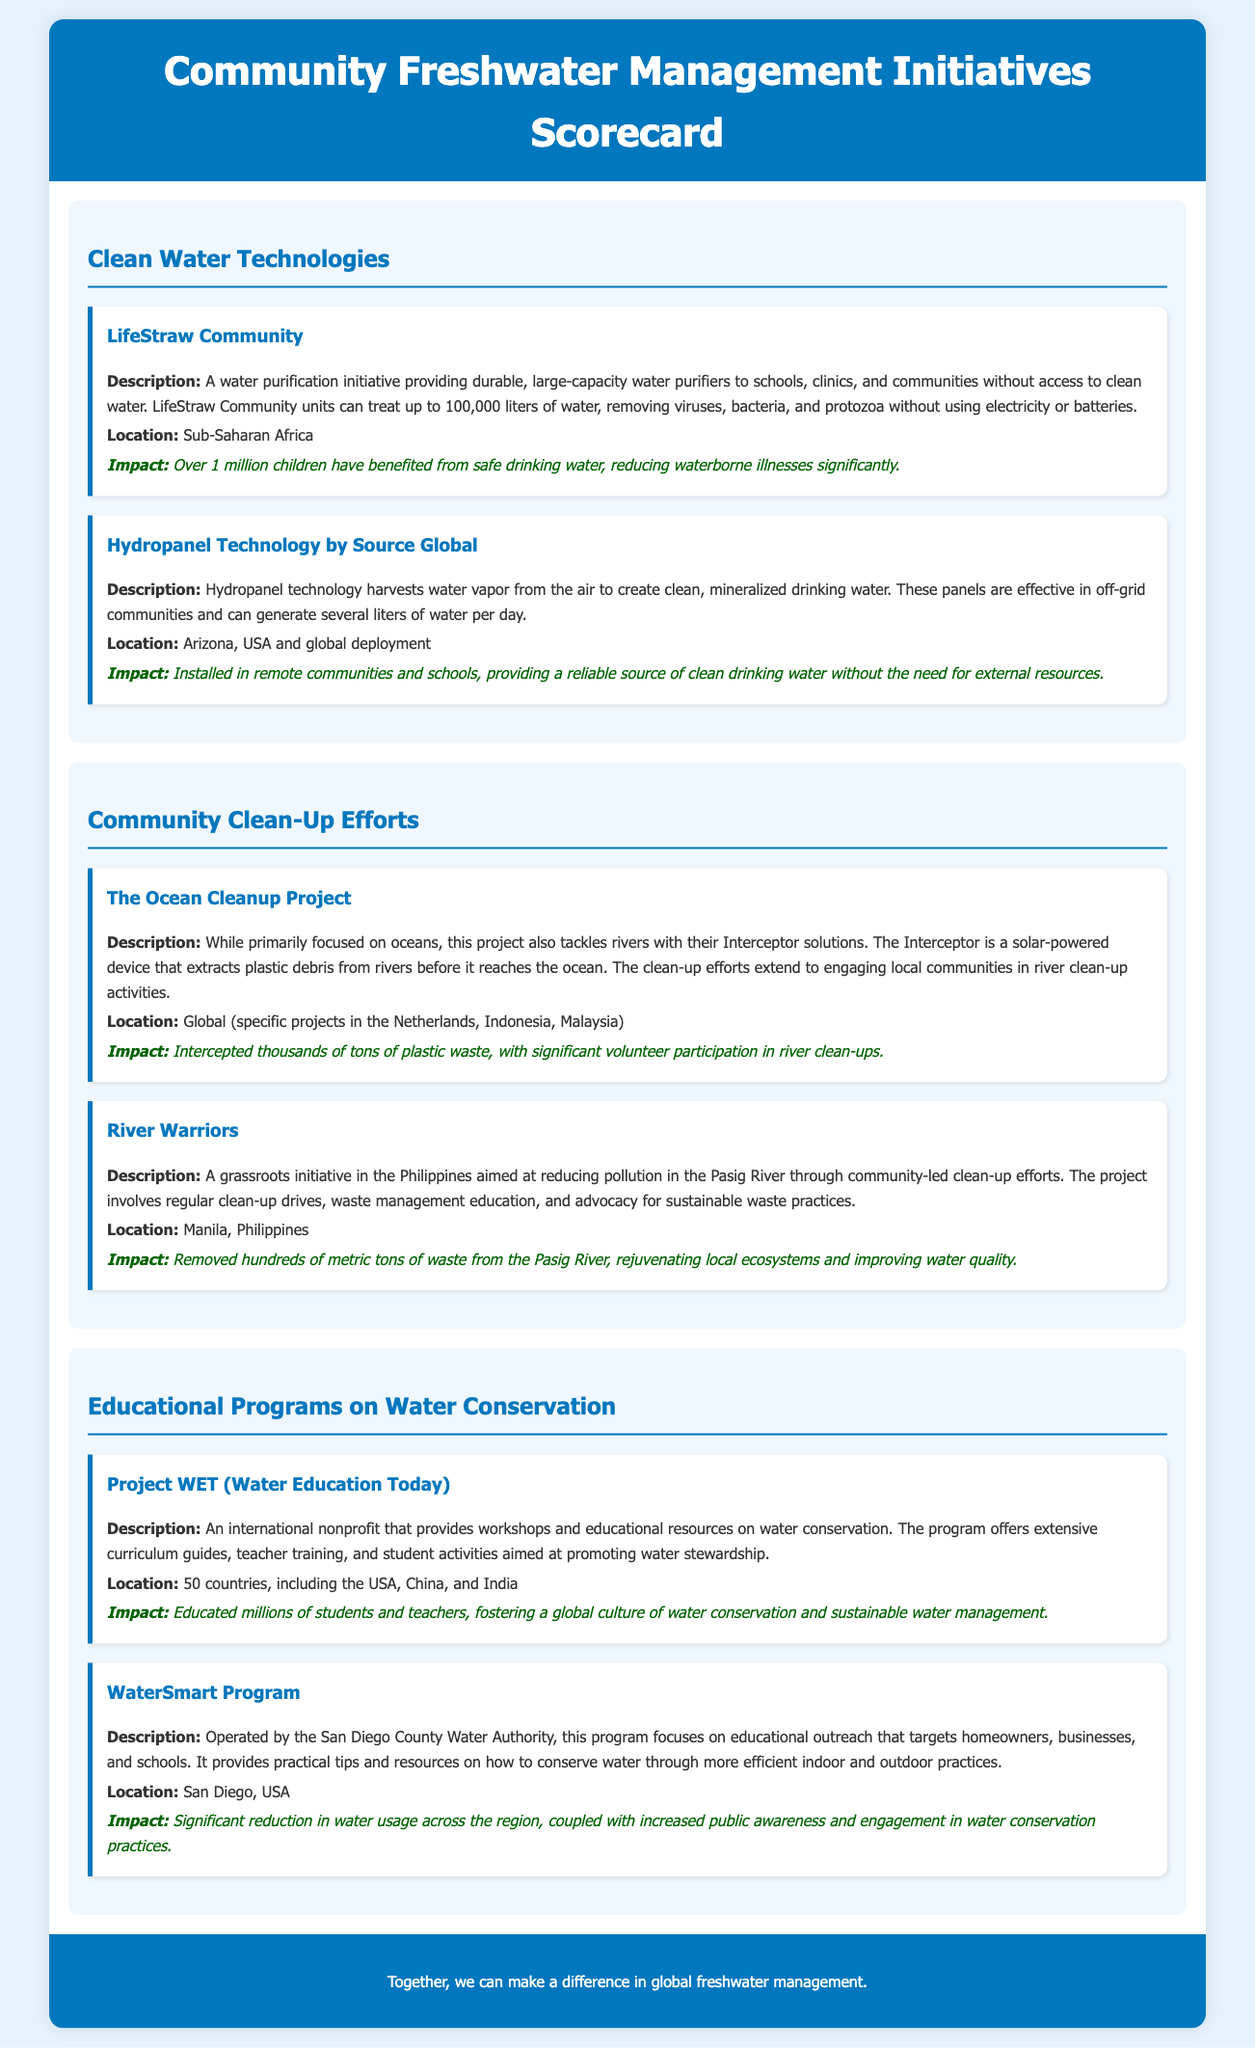What is the title of the scorecard? The title of the scorecard is clearly displayed at the top of the document.
Answer: Community Freshwater Management Initiatives Scorecard How many liters can LifeStraw Community units treat? The document states the capacity of LifeStraw Community units in terms of liters treated.
Answer: 100,000 liters What initiative focuses on water conservation education? This question asks for a specific program mentioned that promotes water conservation education.
Answer: Project WET Where is the River Warriors initiative located? The location of the River Warriors initiative is specified in the document.
Answer: Manila, Philippines What type of technology does Source Global use? This question pertains to the technology implemented by Source Global as described in the document.
Answer: Hydropanel Technology What was one significant outcome of the Ocean Cleanup Project? The document outlines the impact of the Ocean Cleanup Project on waste.
Answer: Intercepted thousands of tons of plastic waste How many countries is Project WET active in? This question seeks a numerical answer regarding the scope of Project WET's operations.
Answer: 50 countries What is the main focus of the WaterSmart Program? The central objective of the WaterSmart Program is discussed in the document.
Answer: Educational outreach What type of device is the Interceptor? The document briefly describes the Interceptor's function.
Answer: Solar-powered device 